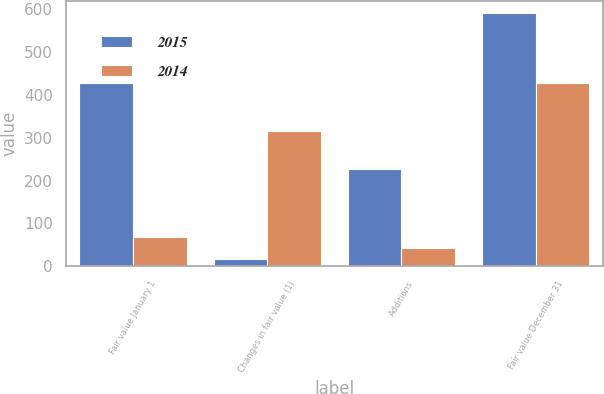Convert chart. <chart><loc_0><loc_0><loc_500><loc_500><stacked_bar_chart><ecel><fcel>Fair value January 1<fcel>Changes in fair value (1)<fcel>Additions<fcel>Fair value December 31<nl><fcel>2015<fcel>428<fcel>16<fcel>228<fcel>590<nl><fcel>2014<fcel>69<fcel>316<fcel>43<fcel>428<nl></chart> 